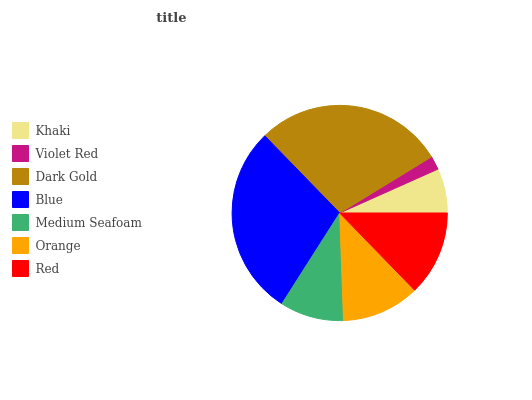Is Violet Red the minimum?
Answer yes or no. Yes. Is Blue the maximum?
Answer yes or no. Yes. Is Dark Gold the minimum?
Answer yes or no. No. Is Dark Gold the maximum?
Answer yes or no. No. Is Dark Gold greater than Violet Red?
Answer yes or no. Yes. Is Violet Red less than Dark Gold?
Answer yes or no. Yes. Is Violet Red greater than Dark Gold?
Answer yes or no. No. Is Dark Gold less than Violet Red?
Answer yes or no. No. Is Orange the high median?
Answer yes or no. Yes. Is Orange the low median?
Answer yes or no. Yes. Is Red the high median?
Answer yes or no. No. Is Red the low median?
Answer yes or no. No. 